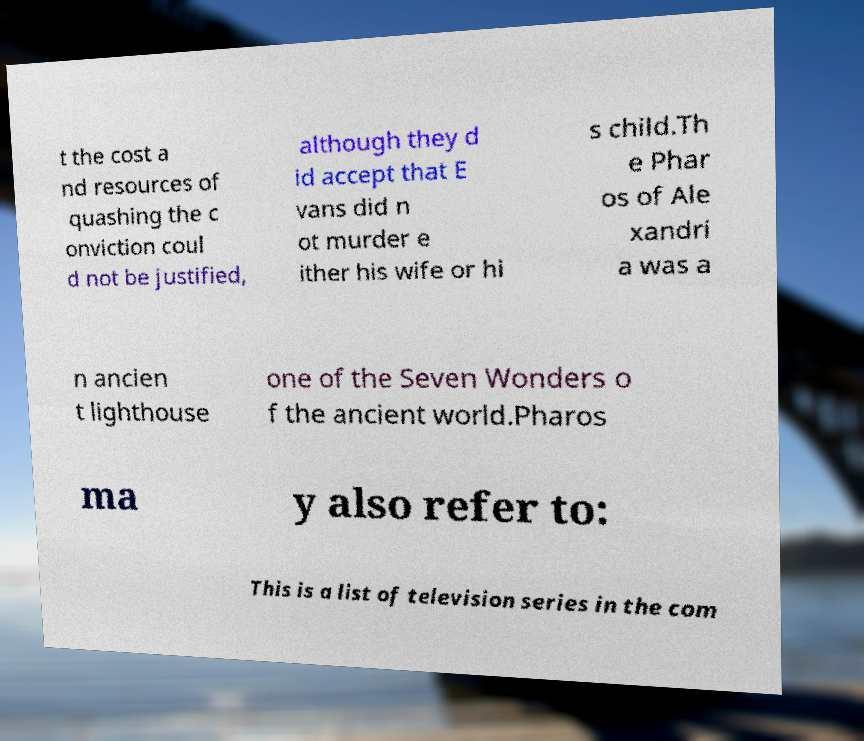For documentation purposes, I need the text within this image transcribed. Could you provide that? t the cost a nd resources of quashing the c onviction coul d not be justified, although they d id accept that E vans did n ot murder e ither his wife or hi s child.Th e Phar os of Ale xandri a was a n ancien t lighthouse one of the Seven Wonders o f the ancient world.Pharos ma y also refer to: This is a list of television series in the com 